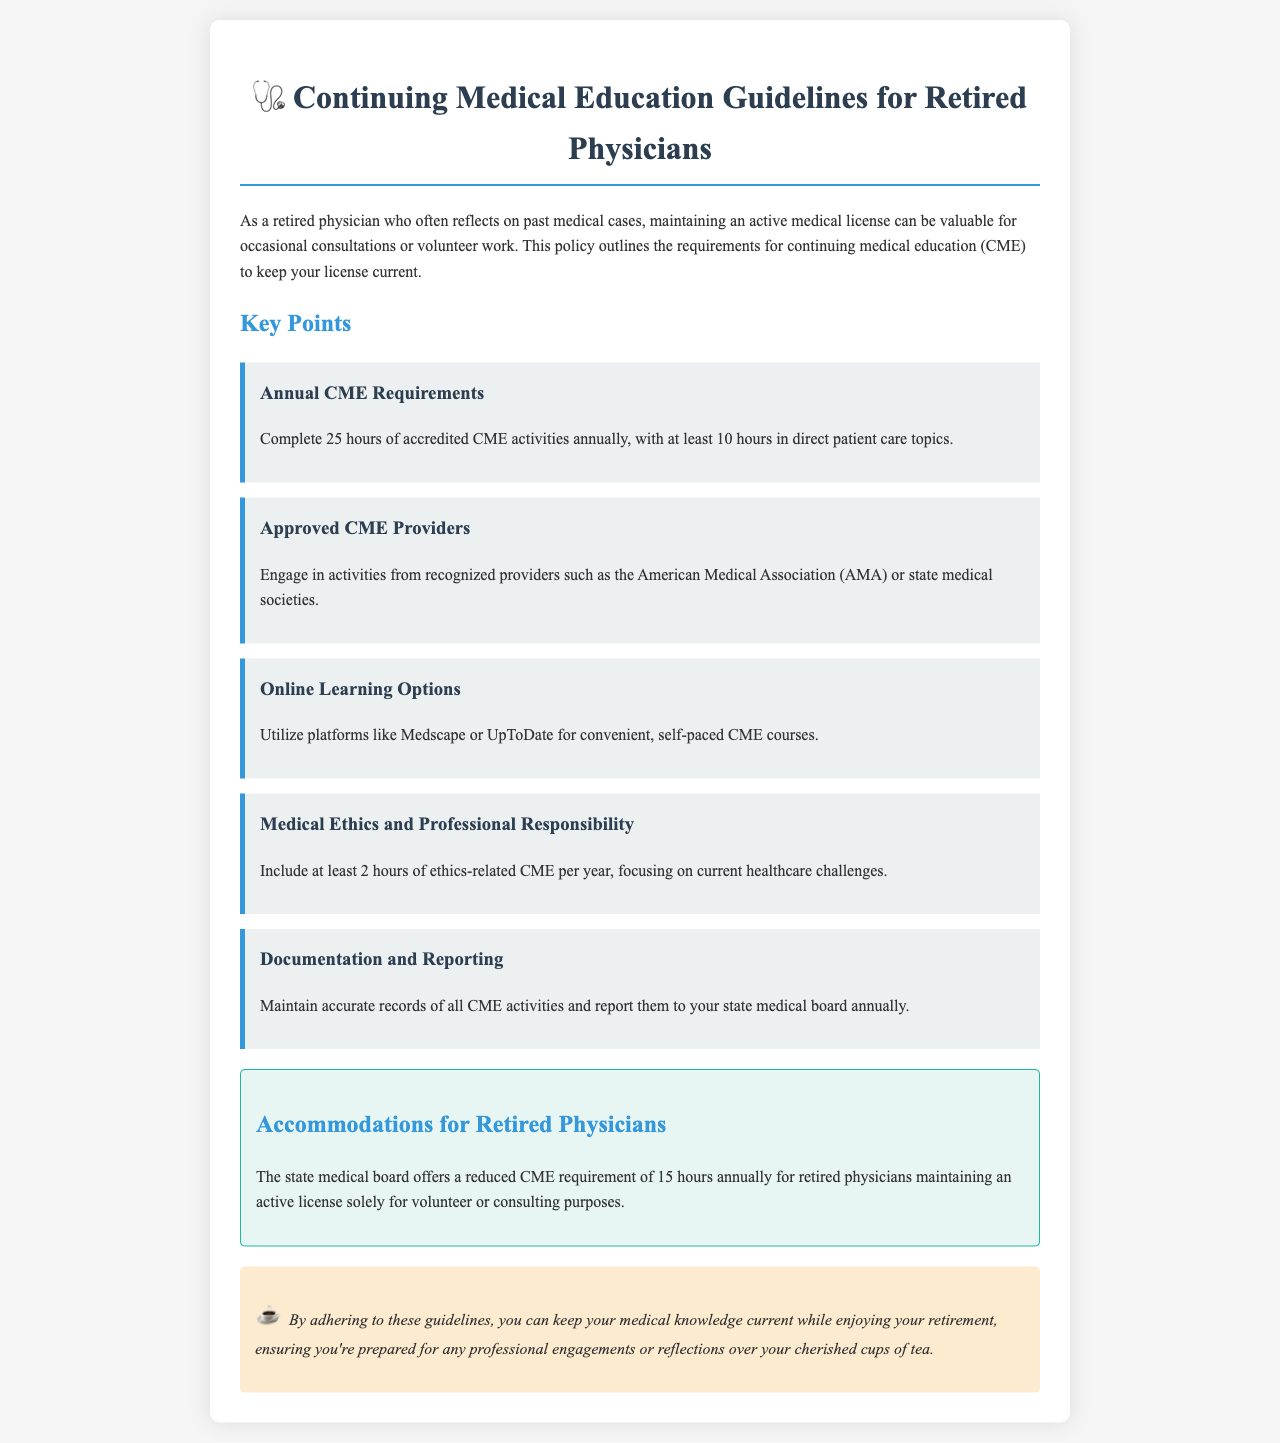What is the annual CME requirement for retired physicians? The document states that the annual CME requirement is 25 hours, with specific hours in certain topics.
Answer: 25 hours How many hours of ethics-related CME are required per year? The policy specifies that at least 2 hours of ethics-related CME must be included each year.
Answer: 2 hours Which organization is mentioned as an approved CME provider? The document lists recognized providers, specifically mentioning the American Medical Association as one of them.
Answer: American Medical Association What is the reduced CME requirement for retired physicians who volunteer? It outlines that there is a reduced requirement of 15 hours annually for those volunteering or consulting.
Answer: 15 hours What platforms can retired physicians use for online CME courses? The document suggests using platforms like Medscape or UpToDate for convenient learning.
Answer: Medscape or UpToDate What is the minimum number of CME hours that must be focused on direct patient care topics? The document indicates that at least 10 hours of CME must specifically be in direct patient care topics.
Answer: 10 hours What should retired physicians maintain regarding their CME activities? Physicians are advised to keep accurate records of their CME activities for reporting purposes.
Answer: Accurate records What type of document is this? The document outlines requirements and guidelines for maintaining a retired doctor's medical license.
Answer: Policy document 